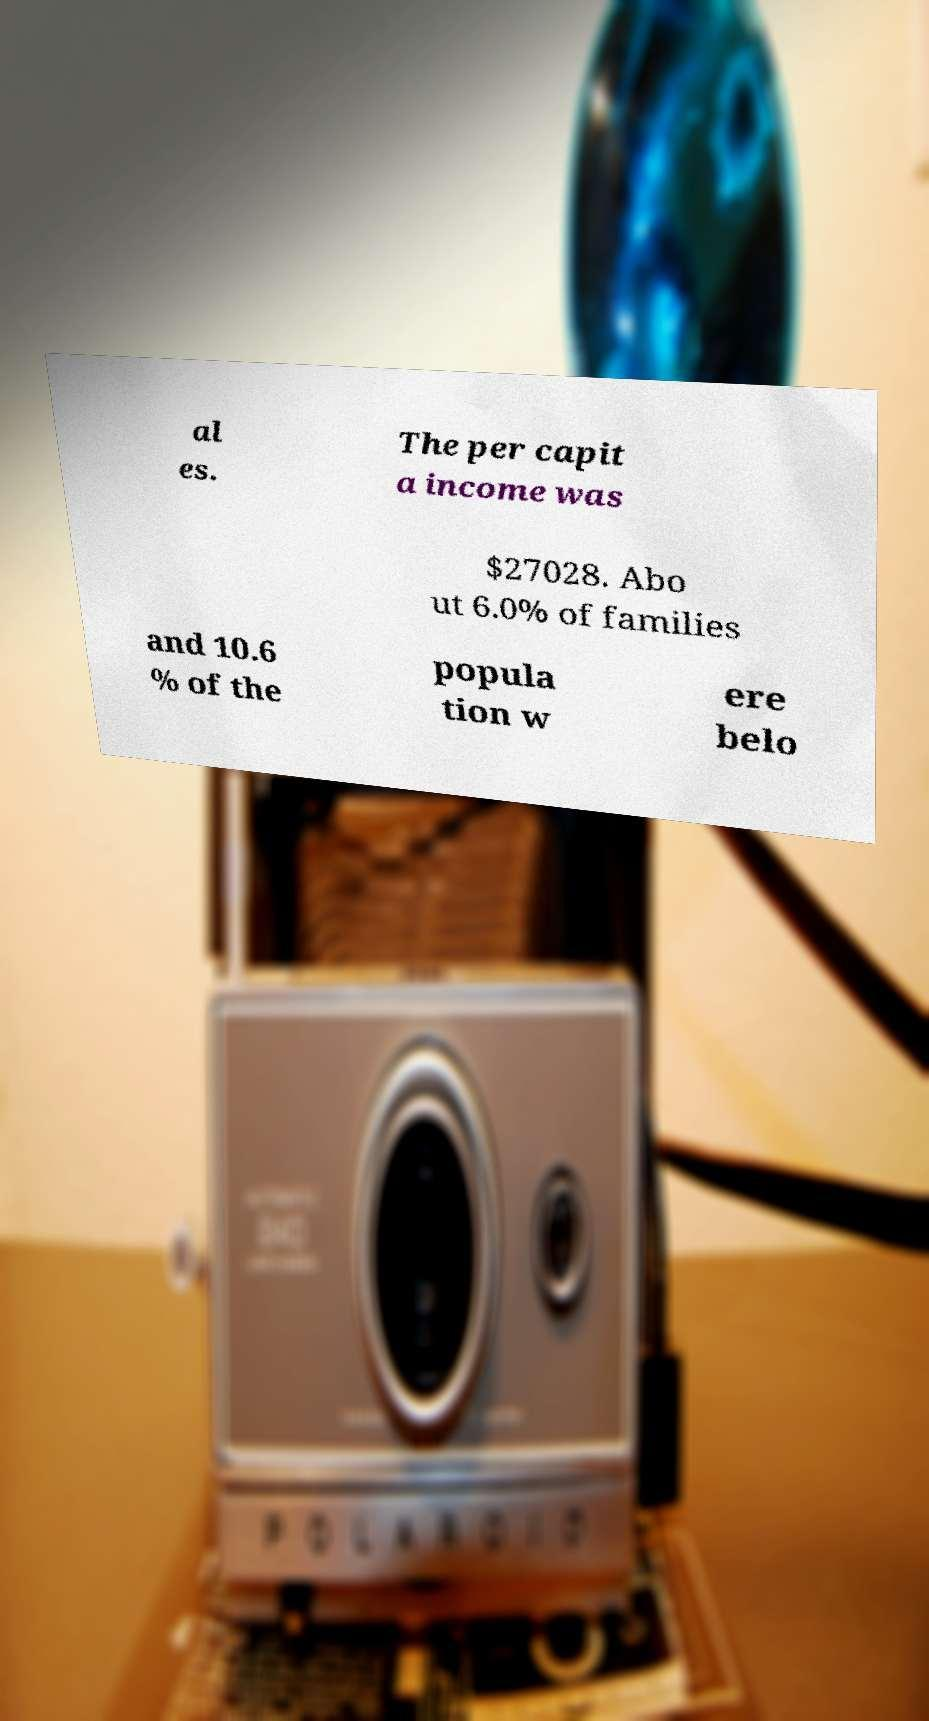I need the written content from this picture converted into text. Can you do that? al es. The per capit a income was $27028. Abo ut 6.0% of families and 10.6 % of the popula tion w ere belo 